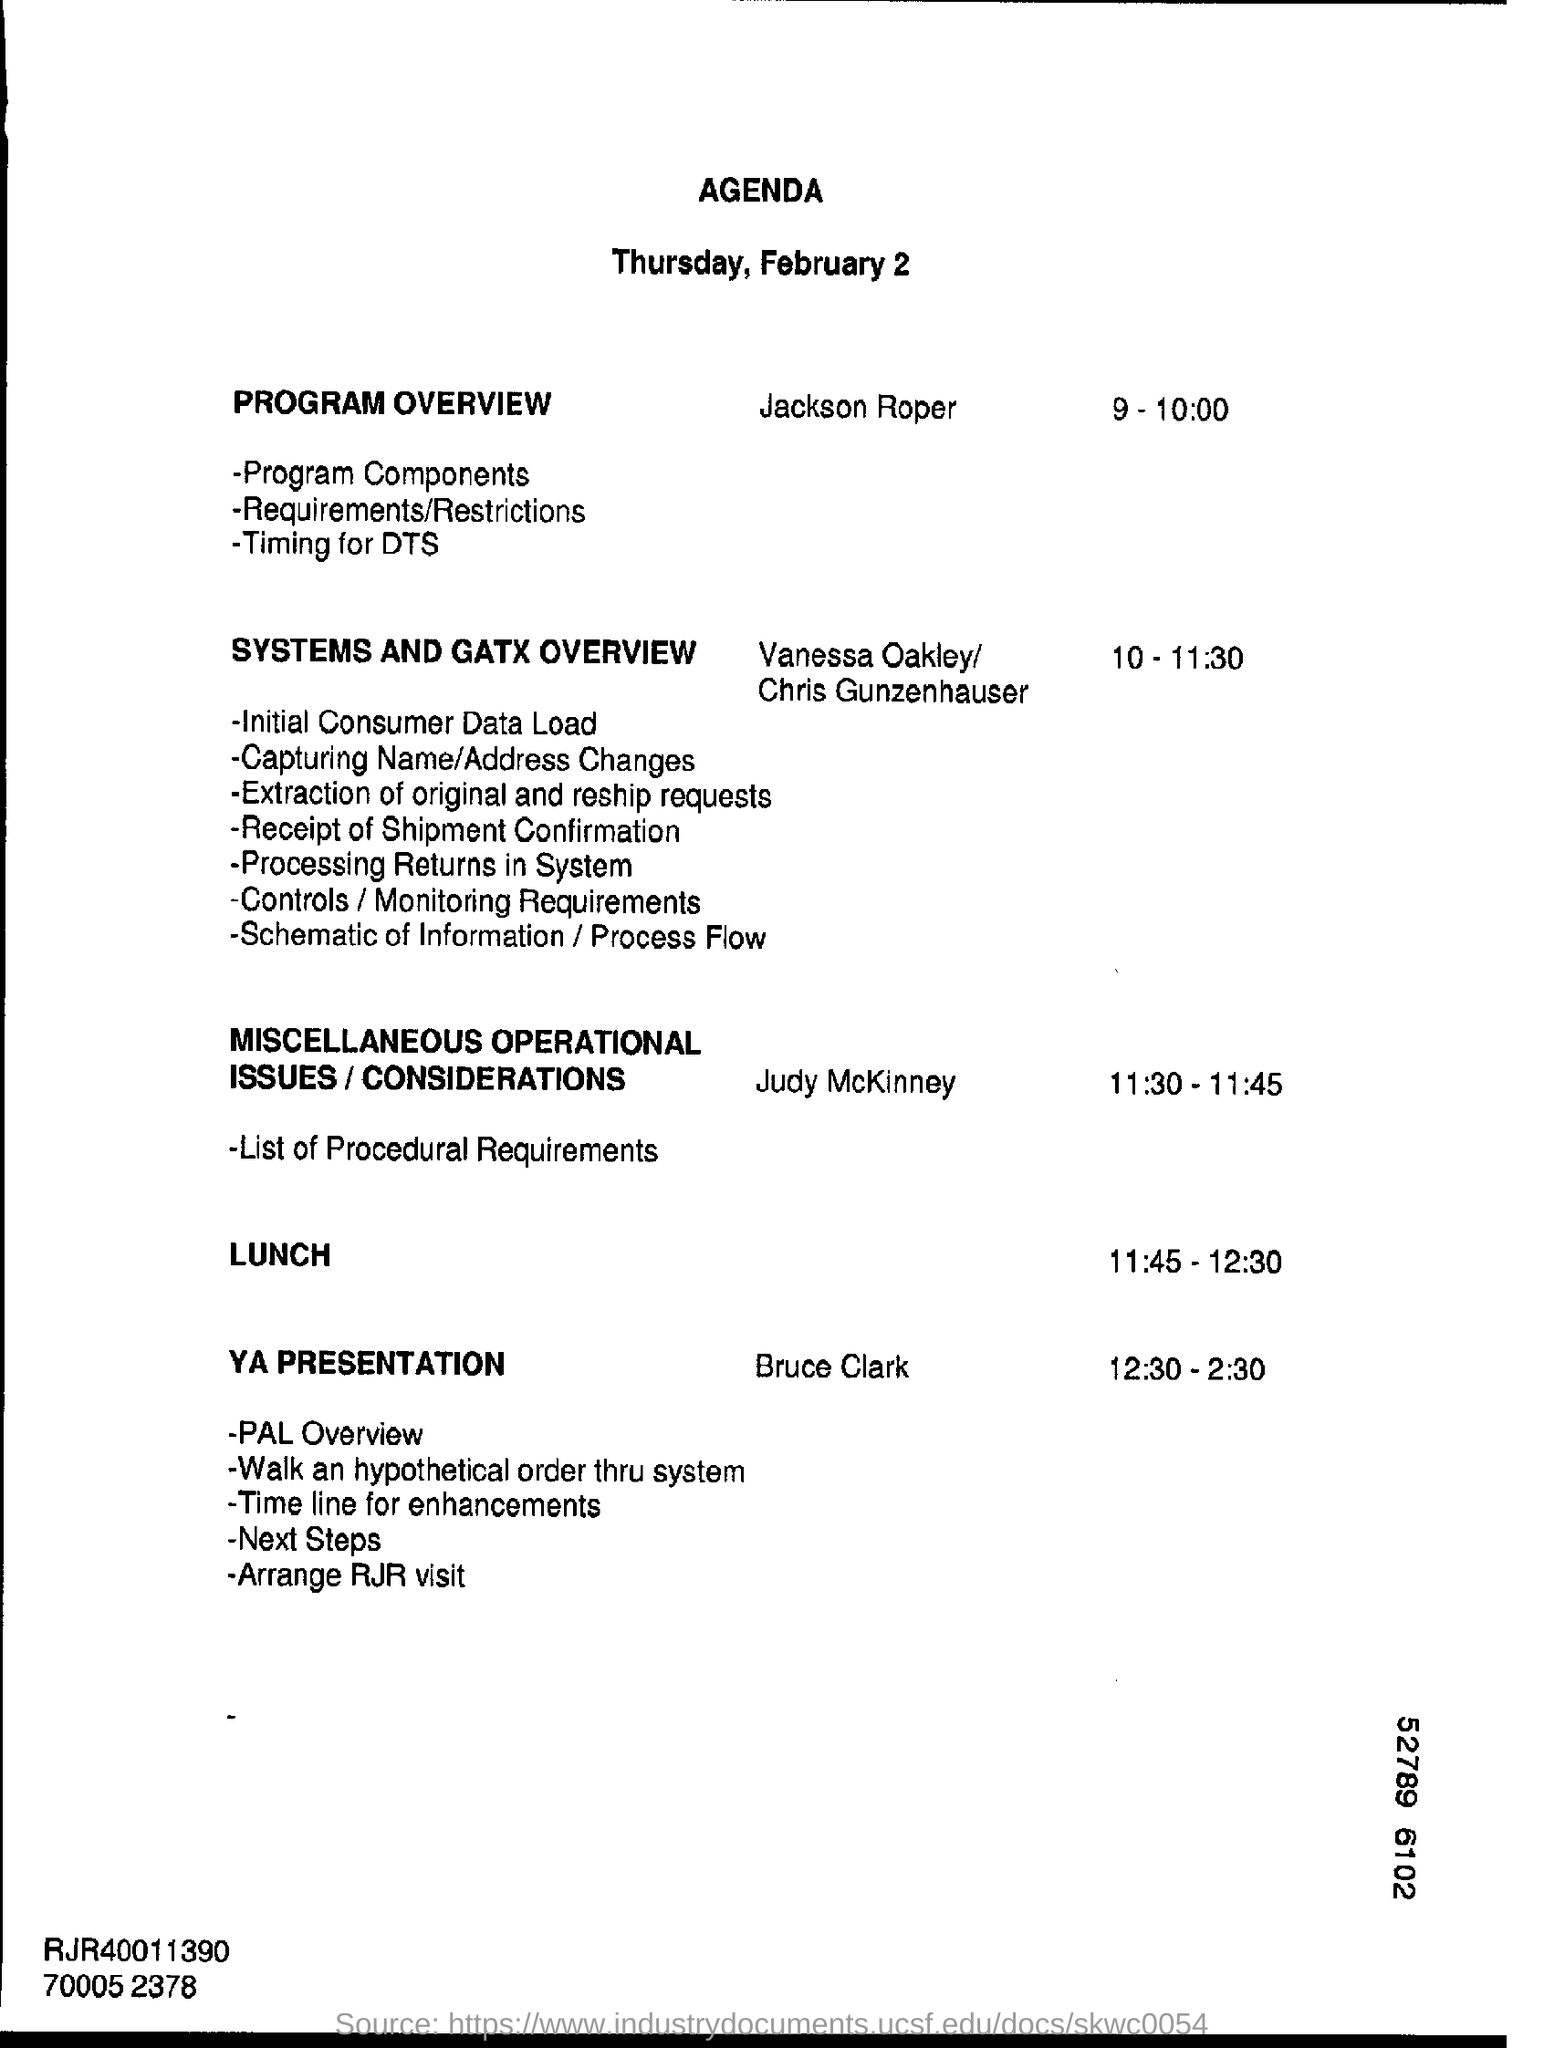What is the date mentioned in the top of the document ?
Provide a succinct answer. Thursday, February 2. What is the Lunch Time as per the agenda?
Your answer should be compact. 11:45 - 12:30. 